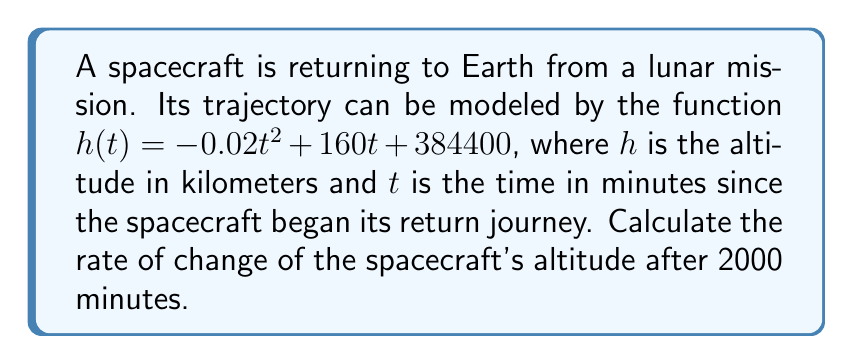Show me your answer to this math problem. To solve this problem, we need to follow these steps:

1) The function $h(t) = -0.02t^2 + 160t + 384400$ represents the altitude of the spacecraft at time $t$.

2) To find the rate of change of altitude, we need to find the derivative of this function with respect to $t$.

3) Using the power rule and constant rule of differentiation:

   $$\frac{dh}{dt} = -0.02 \cdot 2t + 160 + 0$$
   $$\frac{dh}{dt} = -0.04t + 160$$

4) This derivative function represents the instantaneous rate of change of altitude at any time $t$.

5) We're asked to find the rate of change after 2000 minutes, so we need to evaluate $\frac{dh}{dt}$ at $t = 2000$:

   $$\frac{dh}{dt}|_{t=2000} = -0.04(2000) + 160$$
   $$= -80 + 160 = 80$$

6) The units of this rate of change would be kilometers per minute, as altitude is in kilometers and time is in minutes.
Answer: 80 km/min 